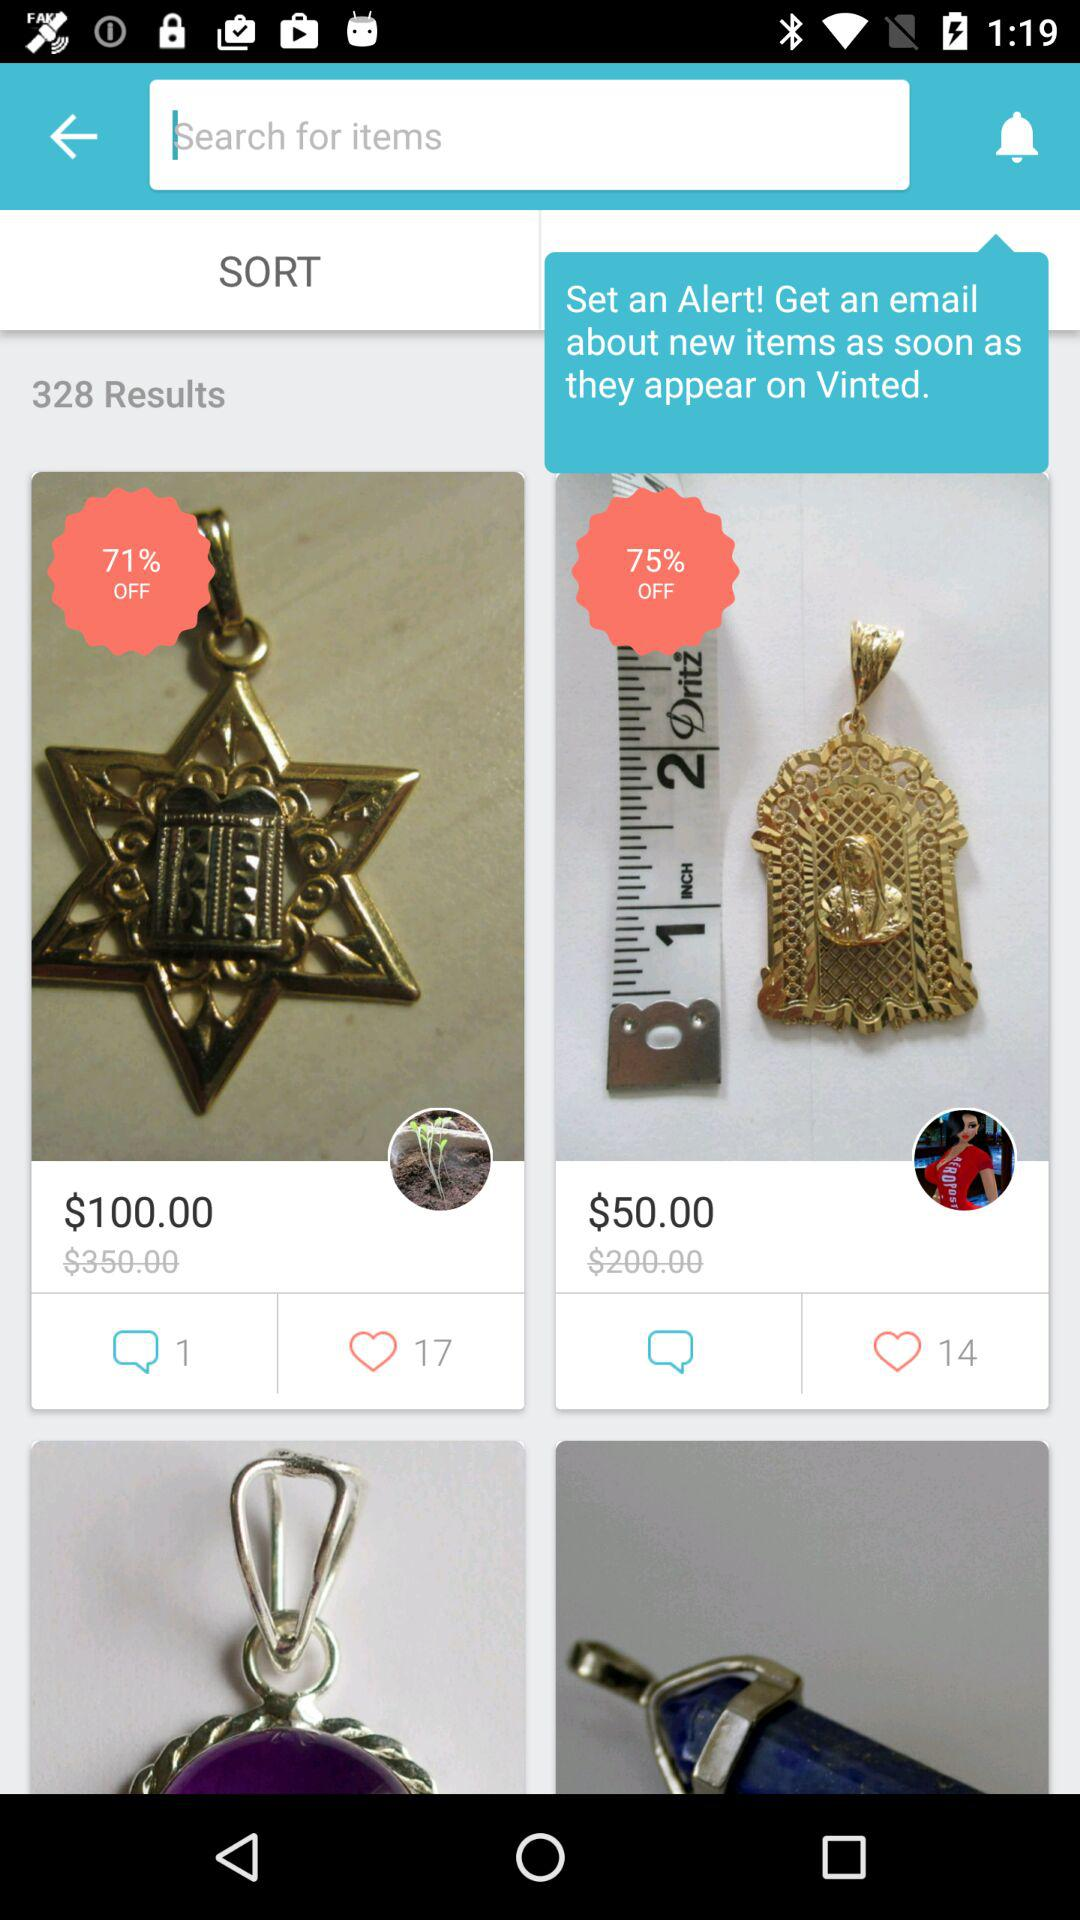How many comments are there for a $100.00 product? There is 1 comment for a $100.00 product. 